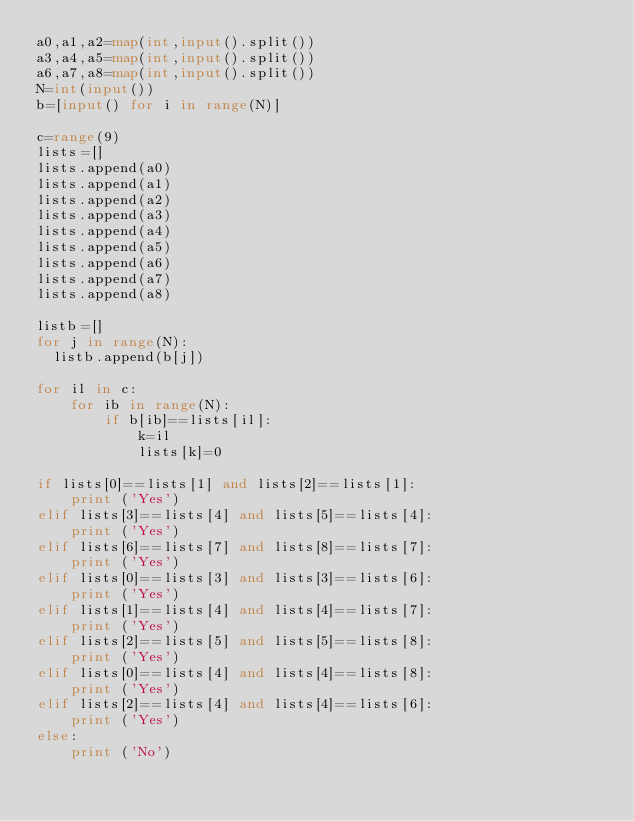Convert code to text. <code><loc_0><loc_0><loc_500><loc_500><_Python_>a0,a1,a2=map(int,input().split())
a3,a4,a5=map(int,input().split())
a6,a7,a8=map(int,input().split())
N=int(input())
b=[input() for i in range(N)]

c=range(9)
lists=[]
lists.append(a0)
lists.append(a1)
lists.append(a2)
lists.append(a3)
lists.append(a4)
lists.append(a5)
lists.append(a6)
lists.append(a7)
lists.append(a8)

listb=[]
for j in range(N):
  listb.append(b[j])

for il in c:
    for ib in range(N):
        if b[ib]==lists[il]:
            k=il
            lists[k]=0
            
if lists[0]==lists[1] and lists[2]==lists[1]:
    print ('Yes')
elif lists[3]==lists[4] and lists[5]==lists[4]:
    print ('Yes')
elif lists[6]==lists[7] and lists[8]==lists[7]:
    print ('Yes')
elif lists[0]==lists[3] and lists[3]==lists[6]:
    print ('Yes')
elif lists[1]==lists[4] and lists[4]==lists[7]:
    print ('Yes')
elif lists[2]==lists[5] and lists[5]==lists[8]:
    print ('Yes')
elif lists[0]==lists[4] and lists[4]==lists[8]:
    print ('Yes')
elif lists[2]==lists[4] and lists[4]==lists[6]:
    print ('Yes')
else:
    print ('No')</code> 